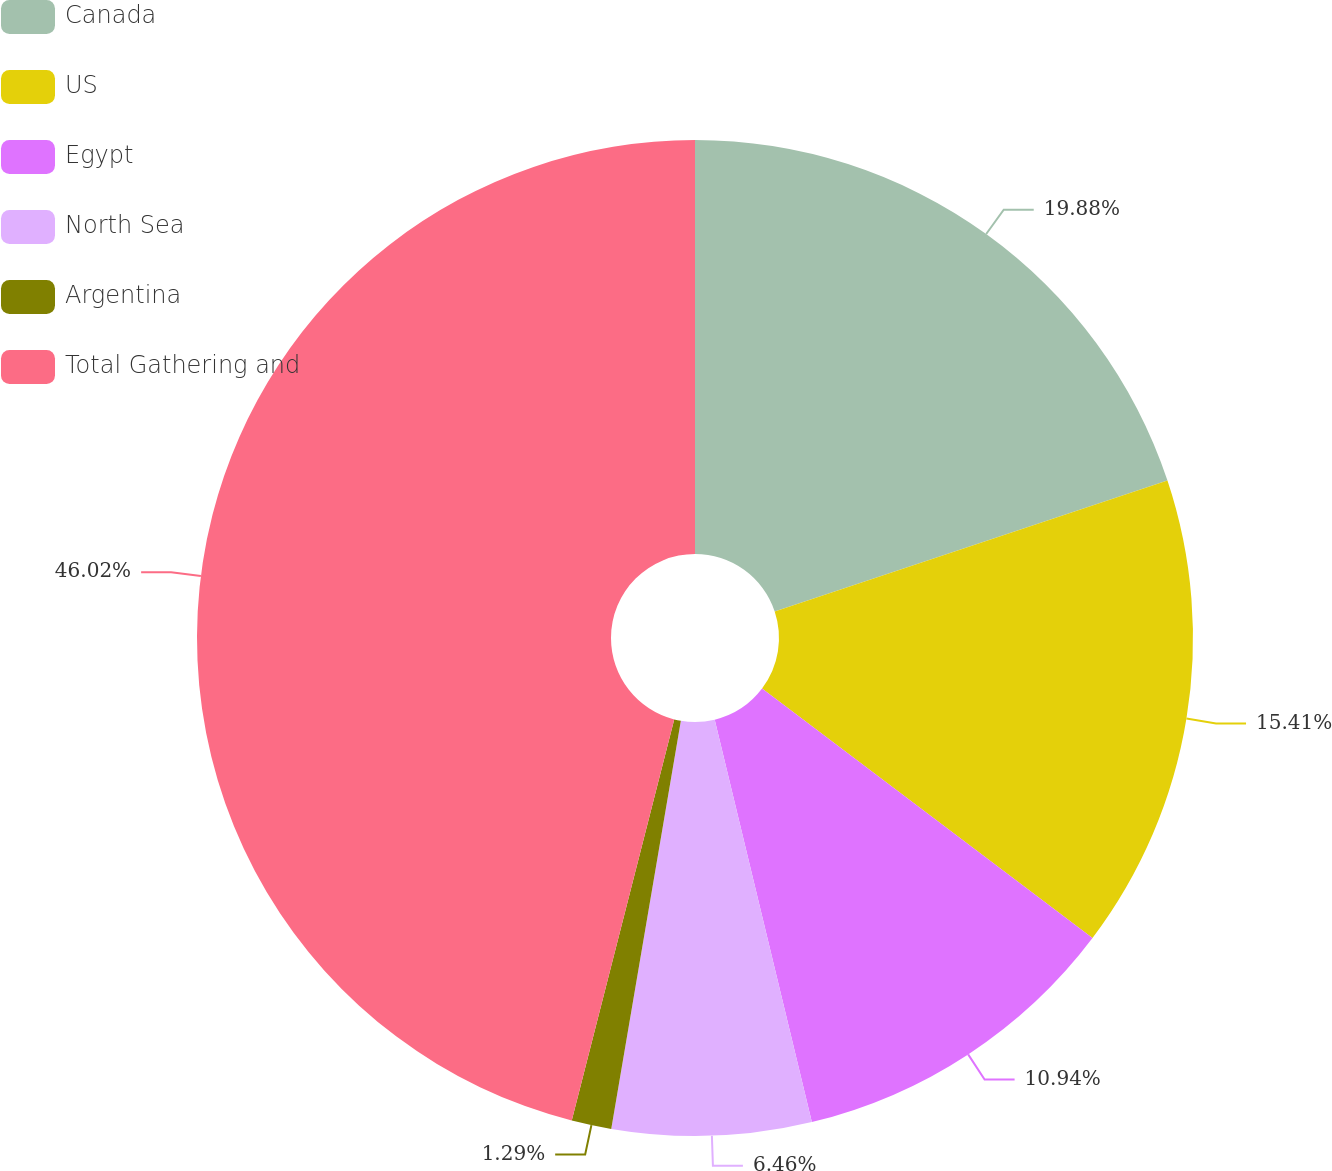Convert chart. <chart><loc_0><loc_0><loc_500><loc_500><pie_chart><fcel>Canada<fcel>US<fcel>Egypt<fcel>North Sea<fcel>Argentina<fcel>Total Gathering and<nl><fcel>19.88%<fcel>15.41%<fcel>10.94%<fcel>6.46%<fcel>1.29%<fcel>46.02%<nl></chart> 